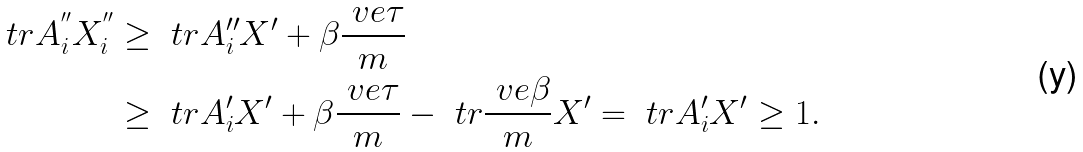<formula> <loc_0><loc_0><loc_500><loc_500>\ t r A _ { i } ^ { ^ { \prime \prime } } X _ { i } ^ { ^ { \prime \prime } } & \geq \ t r A _ { i } ^ { \prime \prime } X ^ { \prime } + \beta \frac { \ v e \tau } { m } \\ & \geq \ t r A _ { i } ^ { \prime } X ^ { \prime } + \beta \frac { \ v e \tau } { m } - \ t r \frac { \ v e \beta } { m } X ^ { \prime } = \ t r A _ { i } ^ { \prime } X ^ { \prime } \geq 1 .</formula> 